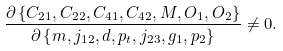Convert formula to latex. <formula><loc_0><loc_0><loc_500><loc_500>\frac { \partial \left \{ C _ { 2 1 } , C _ { 2 2 } , C _ { 4 1 } , C _ { 4 2 } , M , O _ { 1 } , O _ { 2 } \right \} } { \partial \left \{ m , j _ { 1 2 } , d , p _ { t } , j _ { 2 3 } , g _ { 1 } , p _ { 2 } \right \} } \neq 0 .</formula> 